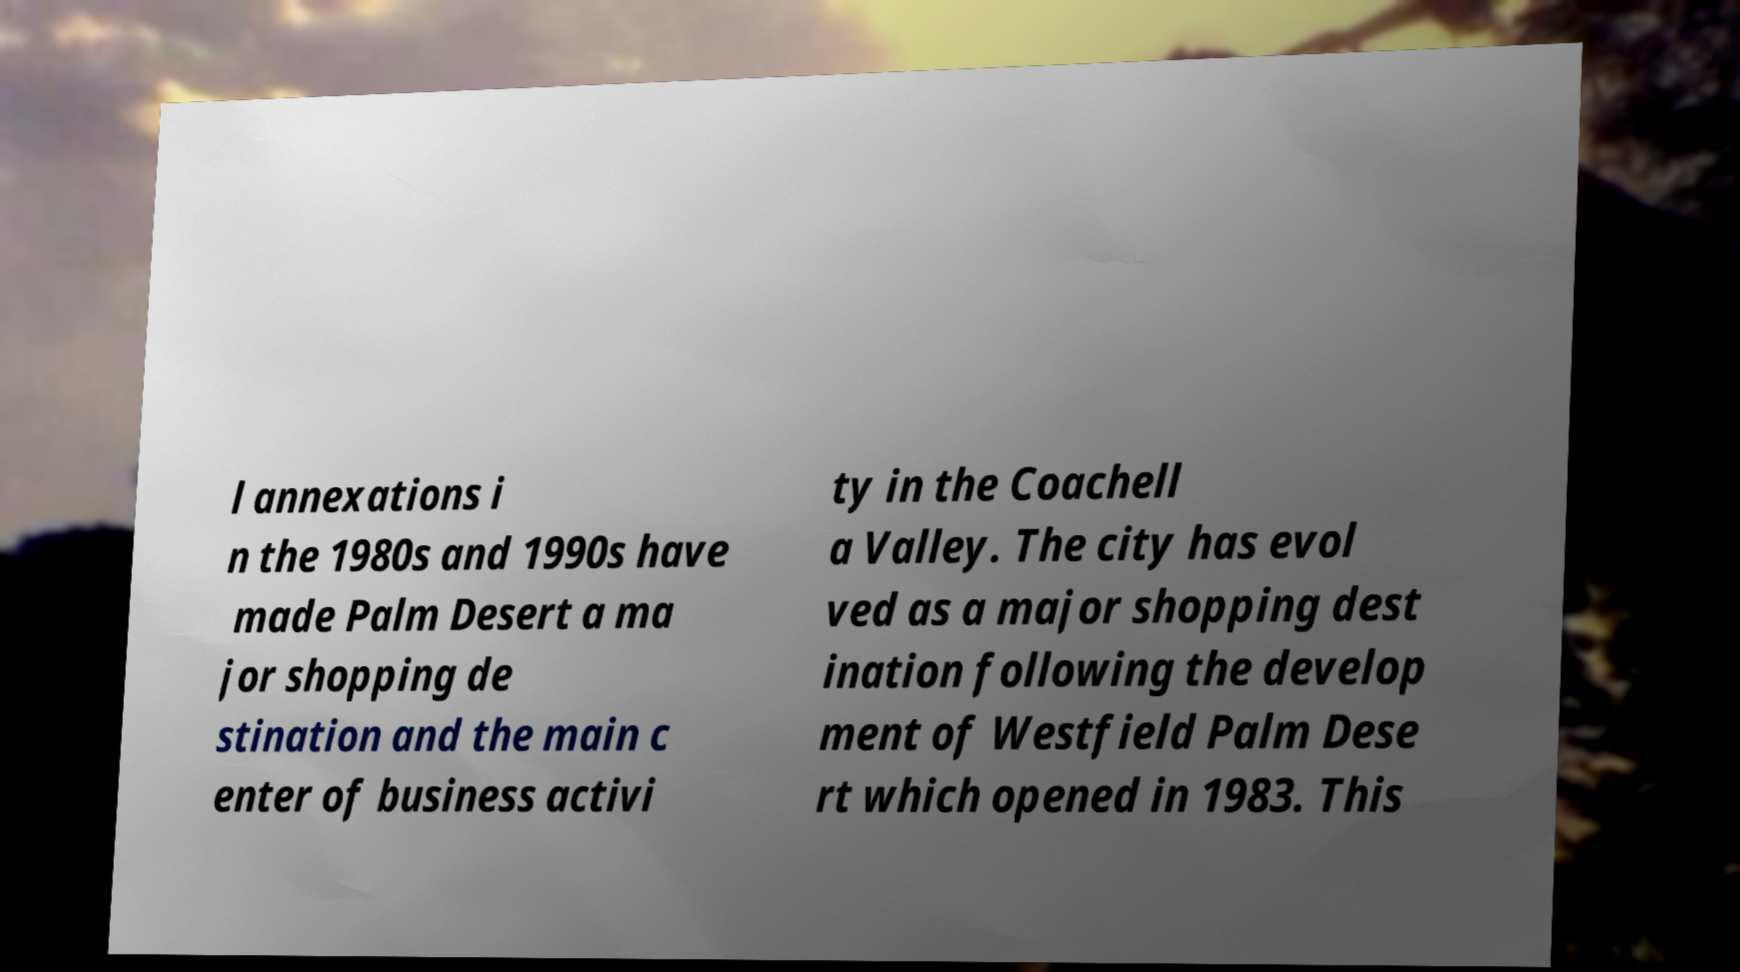Can you accurately transcribe the text from the provided image for me? l annexations i n the 1980s and 1990s have made Palm Desert a ma jor shopping de stination and the main c enter of business activi ty in the Coachell a Valley. The city has evol ved as a major shopping dest ination following the develop ment of Westfield Palm Dese rt which opened in 1983. This 